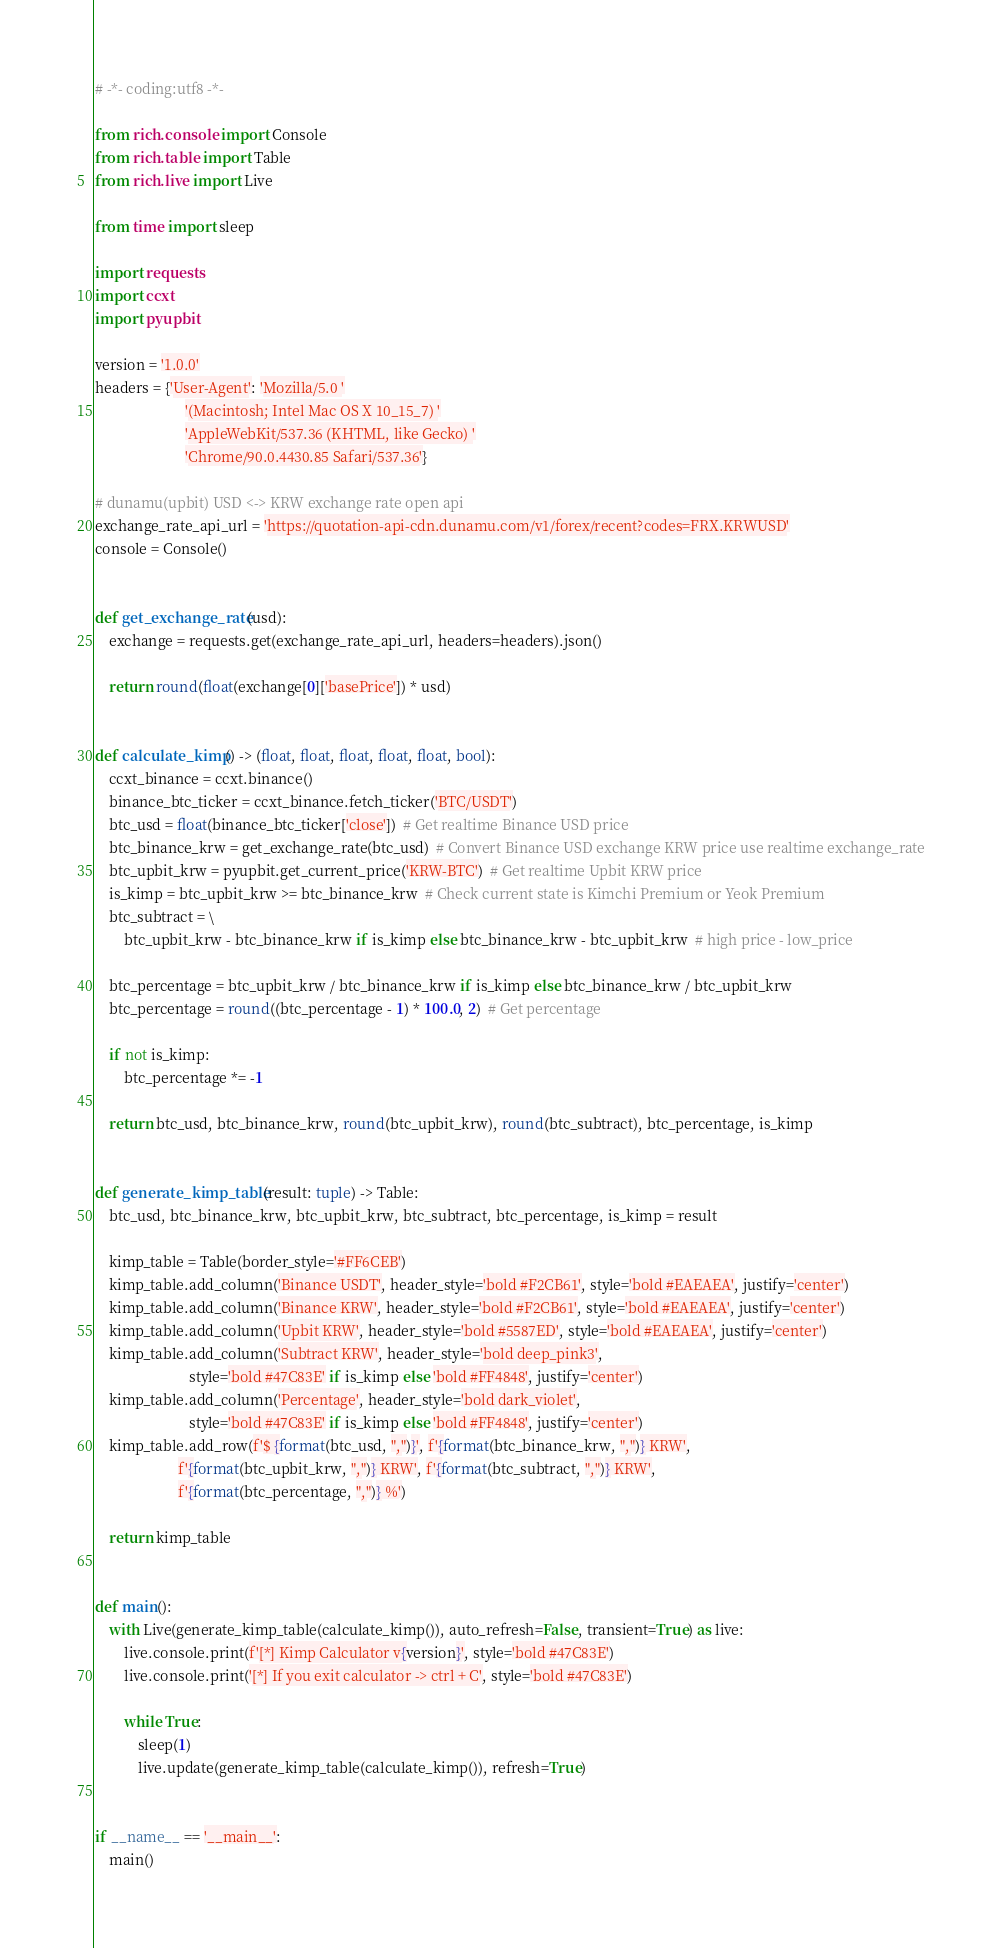<code> <loc_0><loc_0><loc_500><loc_500><_Python_># -*- coding:utf8 -*-

from rich.console import Console
from rich.table import Table
from rich.live import Live

from time import sleep

import requests
import ccxt
import pyupbit

version = '1.0.0'
headers = {'User-Agent': 'Mozilla/5.0 '
                         '(Macintosh; Intel Mac OS X 10_15_7) '
                         'AppleWebKit/537.36 (KHTML, like Gecko) '
                         'Chrome/90.0.4430.85 Safari/537.36'}

# dunamu(upbit) USD <-> KRW exchange rate open api
exchange_rate_api_url = 'https://quotation-api-cdn.dunamu.com/v1/forex/recent?codes=FRX.KRWUSD'
console = Console()


def get_exchange_rate(usd):
    exchange = requests.get(exchange_rate_api_url, headers=headers).json()

    return round(float(exchange[0]['basePrice']) * usd)


def calculate_kimp() -> (float, float, float, float, float, bool):
    ccxt_binance = ccxt.binance()
    binance_btc_ticker = ccxt_binance.fetch_ticker('BTC/USDT')
    btc_usd = float(binance_btc_ticker['close'])  # Get realtime Binance USD price
    btc_binance_krw = get_exchange_rate(btc_usd)  # Convert Binance USD exchange KRW price use realtime exchange_rate
    btc_upbit_krw = pyupbit.get_current_price('KRW-BTC')  # Get realtime Upbit KRW price
    is_kimp = btc_upbit_krw >= btc_binance_krw  # Check current state is Kimchi Premium or Yeok Premium
    btc_subtract = \
        btc_upbit_krw - btc_binance_krw if is_kimp else btc_binance_krw - btc_upbit_krw  # high price - low_price

    btc_percentage = btc_upbit_krw / btc_binance_krw if is_kimp else btc_binance_krw / btc_upbit_krw
    btc_percentage = round((btc_percentage - 1) * 100.0, 2)  # Get percentage

    if not is_kimp:
        btc_percentage *= -1

    return btc_usd, btc_binance_krw, round(btc_upbit_krw), round(btc_subtract), btc_percentage, is_kimp


def generate_kimp_table(result: tuple) -> Table:
    btc_usd, btc_binance_krw, btc_upbit_krw, btc_subtract, btc_percentage, is_kimp = result

    kimp_table = Table(border_style='#FF6CEB')
    kimp_table.add_column('Binance USDT', header_style='bold #F2CB61', style='bold #EAEAEA', justify='center')
    kimp_table.add_column('Binance KRW', header_style='bold #F2CB61', style='bold #EAEAEA', justify='center')
    kimp_table.add_column('Upbit KRW', header_style='bold #5587ED', style='bold #EAEAEA', justify='center')
    kimp_table.add_column('Subtract KRW', header_style='bold deep_pink3',
                          style='bold #47C83E' if is_kimp else 'bold #FF4848', justify='center')
    kimp_table.add_column('Percentage', header_style='bold dark_violet',
                          style='bold #47C83E' if is_kimp else 'bold #FF4848', justify='center')
    kimp_table.add_row(f'$ {format(btc_usd, ",")}', f'{format(btc_binance_krw, ",")} KRW',
                       f'{format(btc_upbit_krw, ",")} KRW', f'{format(btc_subtract, ",")} KRW',
                       f'{format(btc_percentage, ",")} %')

    return kimp_table


def main():
    with Live(generate_kimp_table(calculate_kimp()), auto_refresh=False, transient=True) as live:
        live.console.print(f'[*] Kimp Calculator v{version}', style='bold #47C83E')
        live.console.print('[*] If you exit calculator -> ctrl + C', style='bold #47C83E')

        while True:
            sleep(1)
            live.update(generate_kimp_table(calculate_kimp()), refresh=True)


if __name__ == '__main__':
    main()
</code> 